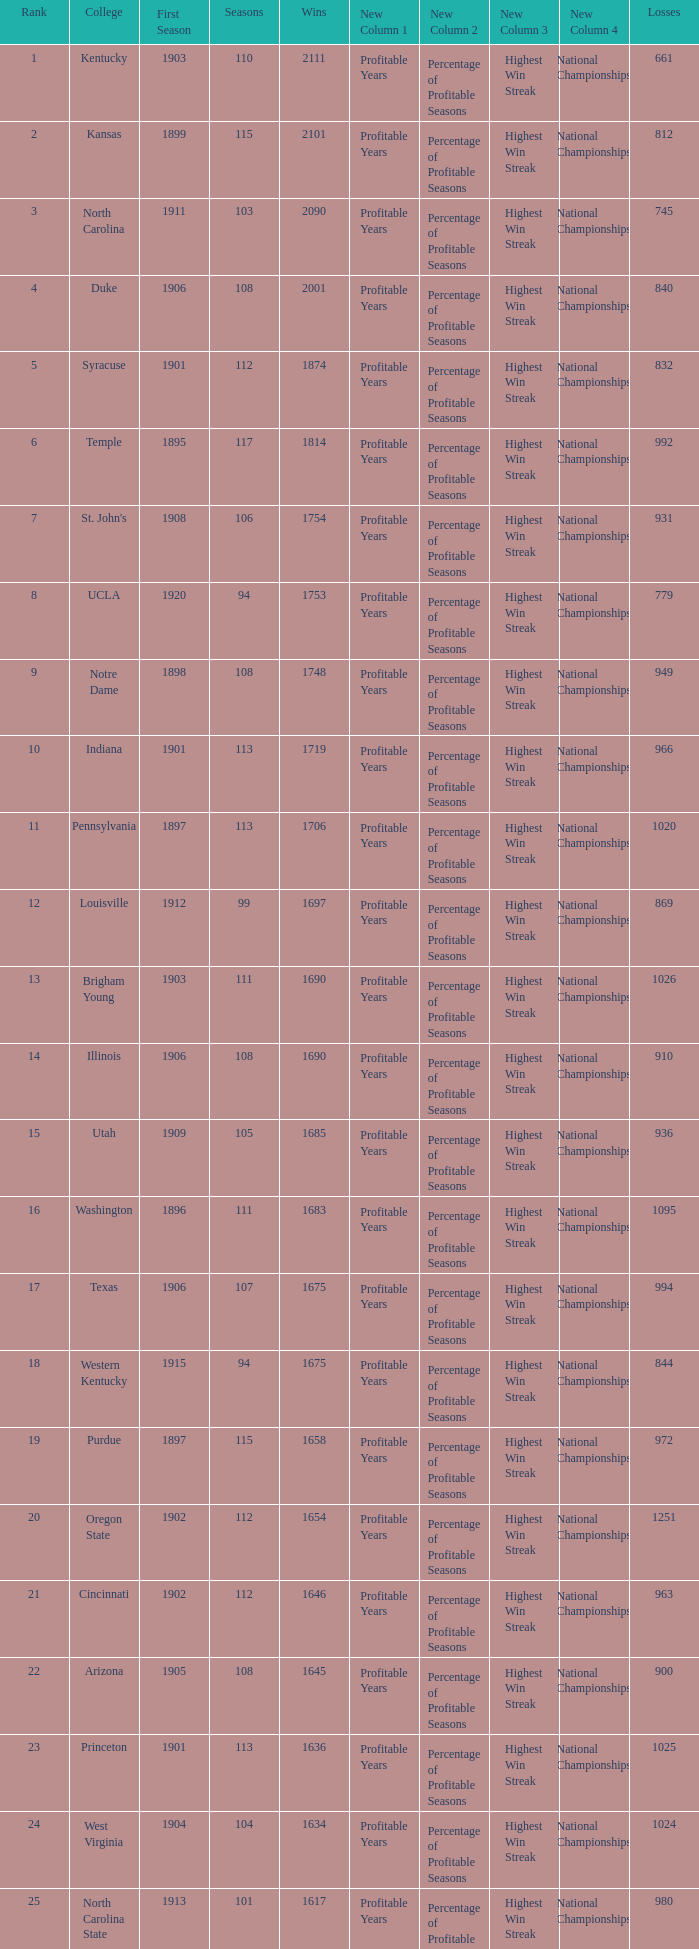How many wins were there for Washington State College with losses greater than 980 and a first season before 1906 and rank greater than 42? 0.0. 